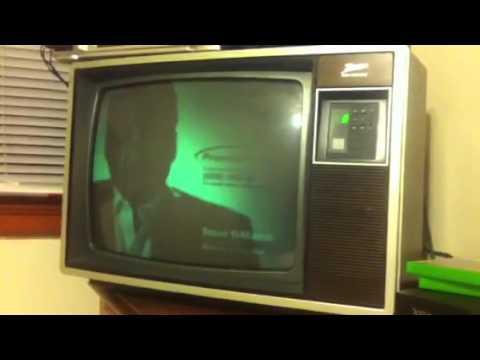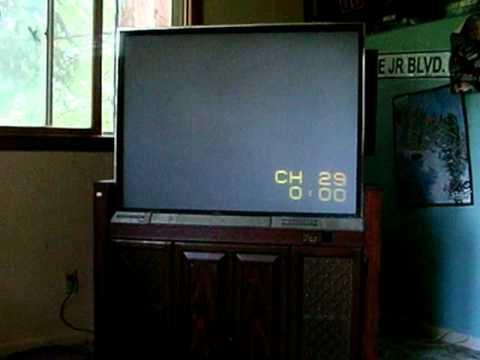The first image is the image on the left, the second image is the image on the right. For the images shown, is this caption "One of the televsions is on." true? Answer yes or no. Yes. 